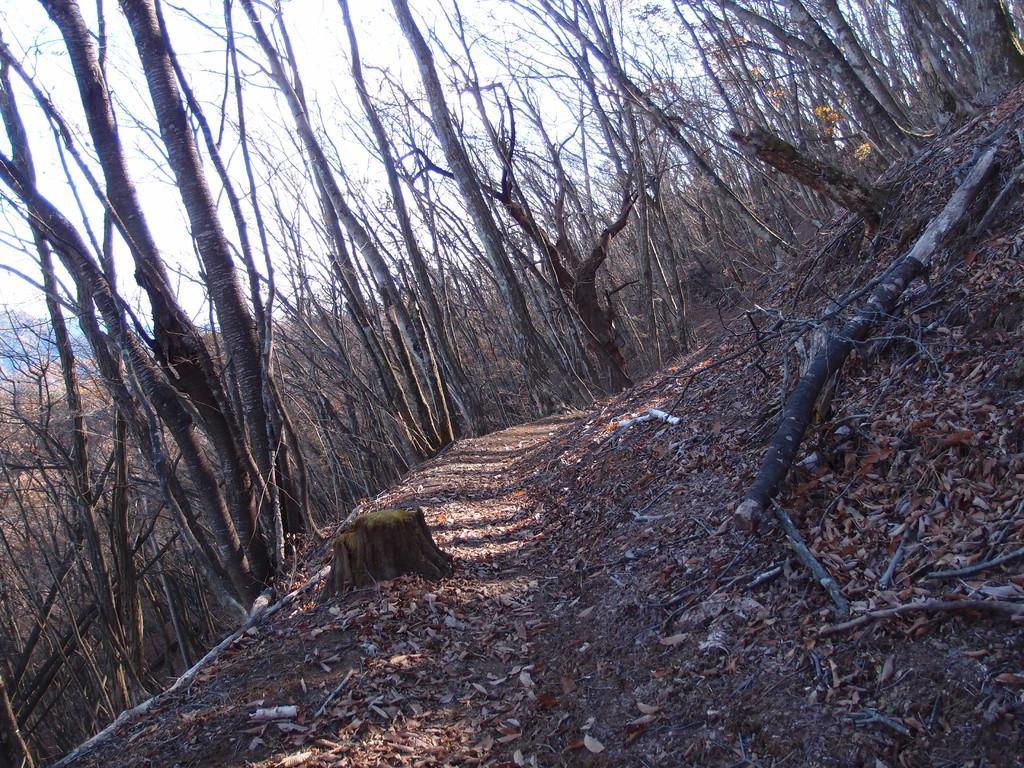Could you give a brief overview of what you see in this image? In this picture I can observe some dried leaves and wooden logs on the ground. There are some trees in this picture. In the background there is a sky. 